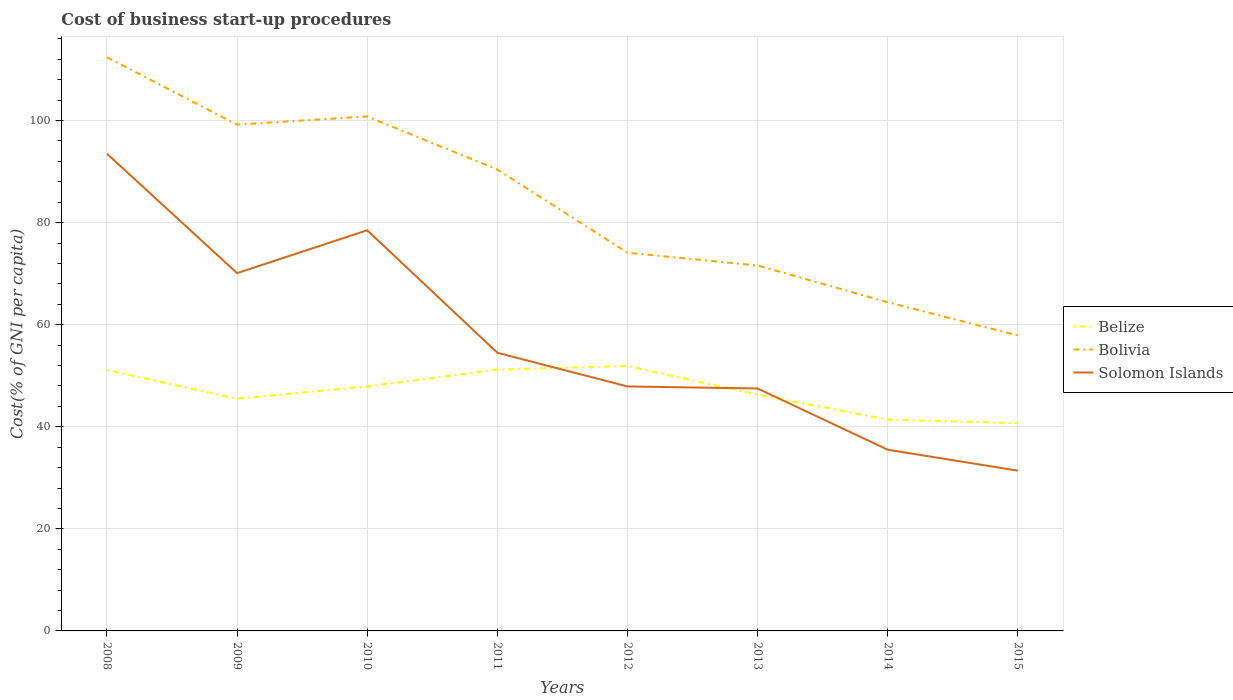How many different coloured lines are there?
Offer a terse response. 3. Across all years, what is the maximum cost of business start-up procedures in Bolivia?
Your answer should be compact. 57.9. In which year was the cost of business start-up procedures in Belize maximum?
Keep it short and to the point. 2015. What is the total cost of business start-up procedures in Bolivia in the graph?
Your answer should be very brief. 27.6. What is the difference between the highest and the second highest cost of business start-up procedures in Solomon Islands?
Give a very brief answer. 62.1. What is the difference between the highest and the lowest cost of business start-up procedures in Bolivia?
Give a very brief answer. 4. Is the cost of business start-up procedures in Solomon Islands strictly greater than the cost of business start-up procedures in Belize over the years?
Ensure brevity in your answer.  No. How many years are there in the graph?
Keep it short and to the point. 8. Does the graph contain grids?
Make the answer very short. Yes. Where does the legend appear in the graph?
Ensure brevity in your answer.  Center right. How many legend labels are there?
Provide a succinct answer. 3. How are the legend labels stacked?
Offer a terse response. Vertical. What is the title of the graph?
Your response must be concise. Cost of business start-up procedures. Does "Cyprus" appear as one of the legend labels in the graph?
Your answer should be very brief. No. What is the label or title of the X-axis?
Keep it short and to the point. Years. What is the label or title of the Y-axis?
Provide a short and direct response. Cost(% of GNI per capita). What is the Cost(% of GNI per capita) of Belize in 2008?
Provide a short and direct response. 51.1. What is the Cost(% of GNI per capita) of Bolivia in 2008?
Ensure brevity in your answer.  112.4. What is the Cost(% of GNI per capita) of Solomon Islands in 2008?
Your answer should be compact. 93.5. What is the Cost(% of GNI per capita) of Belize in 2009?
Your response must be concise. 45.5. What is the Cost(% of GNI per capita) of Bolivia in 2009?
Offer a very short reply. 99.2. What is the Cost(% of GNI per capita) in Solomon Islands in 2009?
Your answer should be compact. 70.1. What is the Cost(% of GNI per capita) in Belize in 2010?
Give a very brief answer. 47.9. What is the Cost(% of GNI per capita) of Bolivia in 2010?
Provide a short and direct response. 100.8. What is the Cost(% of GNI per capita) of Solomon Islands in 2010?
Your answer should be very brief. 78.5. What is the Cost(% of GNI per capita) in Belize in 2011?
Your response must be concise. 51.2. What is the Cost(% of GNI per capita) in Bolivia in 2011?
Keep it short and to the point. 90.4. What is the Cost(% of GNI per capita) in Solomon Islands in 2011?
Your answer should be very brief. 54.5. What is the Cost(% of GNI per capita) of Belize in 2012?
Offer a terse response. 51.9. What is the Cost(% of GNI per capita) of Bolivia in 2012?
Your answer should be very brief. 74.1. What is the Cost(% of GNI per capita) of Solomon Islands in 2012?
Your response must be concise. 47.9. What is the Cost(% of GNI per capita) in Belize in 2013?
Your answer should be compact. 46.3. What is the Cost(% of GNI per capita) of Bolivia in 2013?
Offer a very short reply. 71.6. What is the Cost(% of GNI per capita) in Solomon Islands in 2013?
Keep it short and to the point. 47.5. What is the Cost(% of GNI per capita) in Belize in 2014?
Your response must be concise. 41.4. What is the Cost(% of GNI per capita) in Bolivia in 2014?
Your answer should be compact. 64.4. What is the Cost(% of GNI per capita) of Solomon Islands in 2014?
Provide a succinct answer. 35.5. What is the Cost(% of GNI per capita) of Belize in 2015?
Provide a succinct answer. 40.7. What is the Cost(% of GNI per capita) of Bolivia in 2015?
Your answer should be very brief. 57.9. What is the Cost(% of GNI per capita) in Solomon Islands in 2015?
Provide a short and direct response. 31.4. Across all years, what is the maximum Cost(% of GNI per capita) of Belize?
Your answer should be compact. 51.9. Across all years, what is the maximum Cost(% of GNI per capita) in Bolivia?
Ensure brevity in your answer.  112.4. Across all years, what is the maximum Cost(% of GNI per capita) in Solomon Islands?
Your response must be concise. 93.5. Across all years, what is the minimum Cost(% of GNI per capita) of Belize?
Your answer should be very brief. 40.7. Across all years, what is the minimum Cost(% of GNI per capita) in Bolivia?
Your answer should be compact. 57.9. Across all years, what is the minimum Cost(% of GNI per capita) of Solomon Islands?
Provide a short and direct response. 31.4. What is the total Cost(% of GNI per capita) in Belize in the graph?
Offer a very short reply. 376. What is the total Cost(% of GNI per capita) of Bolivia in the graph?
Your response must be concise. 670.8. What is the total Cost(% of GNI per capita) in Solomon Islands in the graph?
Your answer should be compact. 458.9. What is the difference between the Cost(% of GNI per capita) of Belize in 2008 and that in 2009?
Your answer should be compact. 5.6. What is the difference between the Cost(% of GNI per capita) in Bolivia in 2008 and that in 2009?
Offer a very short reply. 13.2. What is the difference between the Cost(% of GNI per capita) of Solomon Islands in 2008 and that in 2009?
Your answer should be compact. 23.4. What is the difference between the Cost(% of GNI per capita) in Belize in 2008 and that in 2010?
Ensure brevity in your answer.  3.2. What is the difference between the Cost(% of GNI per capita) in Solomon Islands in 2008 and that in 2010?
Provide a succinct answer. 15. What is the difference between the Cost(% of GNI per capita) of Bolivia in 2008 and that in 2011?
Your response must be concise. 22. What is the difference between the Cost(% of GNI per capita) of Solomon Islands in 2008 and that in 2011?
Your answer should be compact. 39. What is the difference between the Cost(% of GNI per capita) of Bolivia in 2008 and that in 2012?
Your answer should be very brief. 38.3. What is the difference between the Cost(% of GNI per capita) of Solomon Islands in 2008 and that in 2012?
Keep it short and to the point. 45.6. What is the difference between the Cost(% of GNI per capita) in Belize in 2008 and that in 2013?
Offer a terse response. 4.8. What is the difference between the Cost(% of GNI per capita) of Bolivia in 2008 and that in 2013?
Give a very brief answer. 40.8. What is the difference between the Cost(% of GNI per capita) of Bolivia in 2008 and that in 2015?
Make the answer very short. 54.5. What is the difference between the Cost(% of GNI per capita) in Solomon Islands in 2008 and that in 2015?
Make the answer very short. 62.1. What is the difference between the Cost(% of GNI per capita) in Belize in 2009 and that in 2010?
Make the answer very short. -2.4. What is the difference between the Cost(% of GNI per capita) in Solomon Islands in 2009 and that in 2010?
Provide a short and direct response. -8.4. What is the difference between the Cost(% of GNI per capita) in Bolivia in 2009 and that in 2011?
Offer a terse response. 8.8. What is the difference between the Cost(% of GNI per capita) in Belize in 2009 and that in 2012?
Keep it short and to the point. -6.4. What is the difference between the Cost(% of GNI per capita) of Bolivia in 2009 and that in 2012?
Your answer should be very brief. 25.1. What is the difference between the Cost(% of GNI per capita) of Solomon Islands in 2009 and that in 2012?
Keep it short and to the point. 22.2. What is the difference between the Cost(% of GNI per capita) in Bolivia in 2009 and that in 2013?
Provide a short and direct response. 27.6. What is the difference between the Cost(% of GNI per capita) in Solomon Islands in 2009 and that in 2013?
Provide a succinct answer. 22.6. What is the difference between the Cost(% of GNI per capita) of Belize in 2009 and that in 2014?
Ensure brevity in your answer.  4.1. What is the difference between the Cost(% of GNI per capita) of Bolivia in 2009 and that in 2014?
Your response must be concise. 34.8. What is the difference between the Cost(% of GNI per capita) in Solomon Islands in 2009 and that in 2014?
Give a very brief answer. 34.6. What is the difference between the Cost(% of GNI per capita) of Belize in 2009 and that in 2015?
Provide a succinct answer. 4.8. What is the difference between the Cost(% of GNI per capita) in Bolivia in 2009 and that in 2015?
Offer a very short reply. 41.3. What is the difference between the Cost(% of GNI per capita) of Solomon Islands in 2009 and that in 2015?
Give a very brief answer. 38.7. What is the difference between the Cost(% of GNI per capita) of Belize in 2010 and that in 2011?
Make the answer very short. -3.3. What is the difference between the Cost(% of GNI per capita) of Bolivia in 2010 and that in 2012?
Provide a succinct answer. 26.7. What is the difference between the Cost(% of GNI per capita) in Solomon Islands in 2010 and that in 2012?
Your answer should be compact. 30.6. What is the difference between the Cost(% of GNI per capita) of Belize in 2010 and that in 2013?
Make the answer very short. 1.6. What is the difference between the Cost(% of GNI per capita) in Bolivia in 2010 and that in 2013?
Offer a terse response. 29.2. What is the difference between the Cost(% of GNI per capita) in Solomon Islands in 2010 and that in 2013?
Make the answer very short. 31. What is the difference between the Cost(% of GNI per capita) of Bolivia in 2010 and that in 2014?
Provide a short and direct response. 36.4. What is the difference between the Cost(% of GNI per capita) of Solomon Islands in 2010 and that in 2014?
Make the answer very short. 43. What is the difference between the Cost(% of GNI per capita) in Belize in 2010 and that in 2015?
Offer a very short reply. 7.2. What is the difference between the Cost(% of GNI per capita) of Bolivia in 2010 and that in 2015?
Your response must be concise. 42.9. What is the difference between the Cost(% of GNI per capita) of Solomon Islands in 2010 and that in 2015?
Keep it short and to the point. 47.1. What is the difference between the Cost(% of GNI per capita) of Belize in 2011 and that in 2012?
Your answer should be compact. -0.7. What is the difference between the Cost(% of GNI per capita) in Bolivia in 2011 and that in 2012?
Your answer should be very brief. 16.3. What is the difference between the Cost(% of GNI per capita) of Belize in 2011 and that in 2013?
Give a very brief answer. 4.9. What is the difference between the Cost(% of GNI per capita) in Bolivia in 2011 and that in 2013?
Your response must be concise. 18.8. What is the difference between the Cost(% of GNI per capita) in Solomon Islands in 2011 and that in 2013?
Ensure brevity in your answer.  7. What is the difference between the Cost(% of GNI per capita) of Bolivia in 2011 and that in 2014?
Your answer should be very brief. 26. What is the difference between the Cost(% of GNI per capita) of Solomon Islands in 2011 and that in 2014?
Ensure brevity in your answer.  19. What is the difference between the Cost(% of GNI per capita) in Belize in 2011 and that in 2015?
Ensure brevity in your answer.  10.5. What is the difference between the Cost(% of GNI per capita) of Bolivia in 2011 and that in 2015?
Provide a succinct answer. 32.5. What is the difference between the Cost(% of GNI per capita) of Solomon Islands in 2011 and that in 2015?
Offer a very short reply. 23.1. What is the difference between the Cost(% of GNI per capita) of Belize in 2012 and that in 2013?
Provide a succinct answer. 5.6. What is the difference between the Cost(% of GNI per capita) of Solomon Islands in 2012 and that in 2014?
Your answer should be very brief. 12.4. What is the difference between the Cost(% of GNI per capita) of Belize in 2012 and that in 2015?
Your answer should be very brief. 11.2. What is the difference between the Cost(% of GNI per capita) in Solomon Islands in 2013 and that in 2014?
Ensure brevity in your answer.  12. What is the difference between the Cost(% of GNI per capita) of Belize in 2013 and that in 2015?
Offer a terse response. 5.6. What is the difference between the Cost(% of GNI per capita) of Belize in 2008 and the Cost(% of GNI per capita) of Bolivia in 2009?
Your answer should be compact. -48.1. What is the difference between the Cost(% of GNI per capita) of Belize in 2008 and the Cost(% of GNI per capita) of Solomon Islands in 2009?
Ensure brevity in your answer.  -19. What is the difference between the Cost(% of GNI per capita) of Bolivia in 2008 and the Cost(% of GNI per capita) of Solomon Islands in 2009?
Offer a very short reply. 42.3. What is the difference between the Cost(% of GNI per capita) in Belize in 2008 and the Cost(% of GNI per capita) in Bolivia in 2010?
Offer a terse response. -49.7. What is the difference between the Cost(% of GNI per capita) in Belize in 2008 and the Cost(% of GNI per capita) in Solomon Islands in 2010?
Provide a short and direct response. -27.4. What is the difference between the Cost(% of GNI per capita) in Bolivia in 2008 and the Cost(% of GNI per capita) in Solomon Islands in 2010?
Offer a very short reply. 33.9. What is the difference between the Cost(% of GNI per capita) in Belize in 2008 and the Cost(% of GNI per capita) in Bolivia in 2011?
Offer a very short reply. -39.3. What is the difference between the Cost(% of GNI per capita) of Bolivia in 2008 and the Cost(% of GNI per capita) of Solomon Islands in 2011?
Give a very brief answer. 57.9. What is the difference between the Cost(% of GNI per capita) in Belize in 2008 and the Cost(% of GNI per capita) in Bolivia in 2012?
Offer a very short reply. -23. What is the difference between the Cost(% of GNI per capita) in Belize in 2008 and the Cost(% of GNI per capita) in Solomon Islands in 2012?
Your response must be concise. 3.2. What is the difference between the Cost(% of GNI per capita) of Bolivia in 2008 and the Cost(% of GNI per capita) of Solomon Islands in 2012?
Make the answer very short. 64.5. What is the difference between the Cost(% of GNI per capita) in Belize in 2008 and the Cost(% of GNI per capita) in Bolivia in 2013?
Your answer should be very brief. -20.5. What is the difference between the Cost(% of GNI per capita) in Bolivia in 2008 and the Cost(% of GNI per capita) in Solomon Islands in 2013?
Offer a very short reply. 64.9. What is the difference between the Cost(% of GNI per capita) in Belize in 2008 and the Cost(% of GNI per capita) in Solomon Islands in 2014?
Give a very brief answer. 15.6. What is the difference between the Cost(% of GNI per capita) in Bolivia in 2008 and the Cost(% of GNI per capita) in Solomon Islands in 2014?
Keep it short and to the point. 76.9. What is the difference between the Cost(% of GNI per capita) of Belize in 2008 and the Cost(% of GNI per capita) of Bolivia in 2015?
Your answer should be compact. -6.8. What is the difference between the Cost(% of GNI per capita) in Bolivia in 2008 and the Cost(% of GNI per capita) in Solomon Islands in 2015?
Ensure brevity in your answer.  81. What is the difference between the Cost(% of GNI per capita) of Belize in 2009 and the Cost(% of GNI per capita) of Bolivia in 2010?
Ensure brevity in your answer.  -55.3. What is the difference between the Cost(% of GNI per capita) in Belize in 2009 and the Cost(% of GNI per capita) in Solomon Islands in 2010?
Offer a terse response. -33. What is the difference between the Cost(% of GNI per capita) of Bolivia in 2009 and the Cost(% of GNI per capita) of Solomon Islands in 2010?
Your answer should be compact. 20.7. What is the difference between the Cost(% of GNI per capita) in Belize in 2009 and the Cost(% of GNI per capita) in Bolivia in 2011?
Keep it short and to the point. -44.9. What is the difference between the Cost(% of GNI per capita) in Bolivia in 2009 and the Cost(% of GNI per capita) in Solomon Islands in 2011?
Your answer should be very brief. 44.7. What is the difference between the Cost(% of GNI per capita) of Belize in 2009 and the Cost(% of GNI per capita) of Bolivia in 2012?
Offer a terse response. -28.6. What is the difference between the Cost(% of GNI per capita) of Belize in 2009 and the Cost(% of GNI per capita) of Solomon Islands in 2012?
Offer a very short reply. -2.4. What is the difference between the Cost(% of GNI per capita) in Bolivia in 2009 and the Cost(% of GNI per capita) in Solomon Islands in 2012?
Your answer should be compact. 51.3. What is the difference between the Cost(% of GNI per capita) in Belize in 2009 and the Cost(% of GNI per capita) in Bolivia in 2013?
Keep it short and to the point. -26.1. What is the difference between the Cost(% of GNI per capita) of Bolivia in 2009 and the Cost(% of GNI per capita) of Solomon Islands in 2013?
Offer a terse response. 51.7. What is the difference between the Cost(% of GNI per capita) in Belize in 2009 and the Cost(% of GNI per capita) in Bolivia in 2014?
Your answer should be very brief. -18.9. What is the difference between the Cost(% of GNI per capita) in Belize in 2009 and the Cost(% of GNI per capita) in Solomon Islands in 2014?
Make the answer very short. 10. What is the difference between the Cost(% of GNI per capita) in Bolivia in 2009 and the Cost(% of GNI per capita) in Solomon Islands in 2014?
Provide a short and direct response. 63.7. What is the difference between the Cost(% of GNI per capita) in Belize in 2009 and the Cost(% of GNI per capita) in Bolivia in 2015?
Offer a terse response. -12.4. What is the difference between the Cost(% of GNI per capita) in Belize in 2009 and the Cost(% of GNI per capita) in Solomon Islands in 2015?
Provide a short and direct response. 14.1. What is the difference between the Cost(% of GNI per capita) of Bolivia in 2009 and the Cost(% of GNI per capita) of Solomon Islands in 2015?
Make the answer very short. 67.8. What is the difference between the Cost(% of GNI per capita) of Belize in 2010 and the Cost(% of GNI per capita) of Bolivia in 2011?
Provide a succinct answer. -42.5. What is the difference between the Cost(% of GNI per capita) of Bolivia in 2010 and the Cost(% of GNI per capita) of Solomon Islands in 2011?
Your answer should be very brief. 46.3. What is the difference between the Cost(% of GNI per capita) of Belize in 2010 and the Cost(% of GNI per capita) of Bolivia in 2012?
Offer a terse response. -26.2. What is the difference between the Cost(% of GNI per capita) in Belize in 2010 and the Cost(% of GNI per capita) in Solomon Islands in 2012?
Your answer should be compact. 0. What is the difference between the Cost(% of GNI per capita) in Bolivia in 2010 and the Cost(% of GNI per capita) in Solomon Islands in 2012?
Ensure brevity in your answer.  52.9. What is the difference between the Cost(% of GNI per capita) in Belize in 2010 and the Cost(% of GNI per capita) in Bolivia in 2013?
Your answer should be compact. -23.7. What is the difference between the Cost(% of GNI per capita) in Bolivia in 2010 and the Cost(% of GNI per capita) in Solomon Islands in 2013?
Give a very brief answer. 53.3. What is the difference between the Cost(% of GNI per capita) of Belize in 2010 and the Cost(% of GNI per capita) of Bolivia in 2014?
Your answer should be very brief. -16.5. What is the difference between the Cost(% of GNI per capita) of Bolivia in 2010 and the Cost(% of GNI per capita) of Solomon Islands in 2014?
Provide a short and direct response. 65.3. What is the difference between the Cost(% of GNI per capita) in Bolivia in 2010 and the Cost(% of GNI per capita) in Solomon Islands in 2015?
Make the answer very short. 69.4. What is the difference between the Cost(% of GNI per capita) of Belize in 2011 and the Cost(% of GNI per capita) of Bolivia in 2012?
Your answer should be very brief. -22.9. What is the difference between the Cost(% of GNI per capita) in Belize in 2011 and the Cost(% of GNI per capita) in Solomon Islands in 2012?
Provide a succinct answer. 3.3. What is the difference between the Cost(% of GNI per capita) of Bolivia in 2011 and the Cost(% of GNI per capita) of Solomon Islands in 2012?
Offer a very short reply. 42.5. What is the difference between the Cost(% of GNI per capita) of Belize in 2011 and the Cost(% of GNI per capita) of Bolivia in 2013?
Your answer should be very brief. -20.4. What is the difference between the Cost(% of GNI per capita) in Bolivia in 2011 and the Cost(% of GNI per capita) in Solomon Islands in 2013?
Give a very brief answer. 42.9. What is the difference between the Cost(% of GNI per capita) of Belize in 2011 and the Cost(% of GNI per capita) of Bolivia in 2014?
Your answer should be compact. -13.2. What is the difference between the Cost(% of GNI per capita) in Belize in 2011 and the Cost(% of GNI per capita) in Solomon Islands in 2014?
Offer a very short reply. 15.7. What is the difference between the Cost(% of GNI per capita) of Bolivia in 2011 and the Cost(% of GNI per capita) of Solomon Islands in 2014?
Your answer should be compact. 54.9. What is the difference between the Cost(% of GNI per capita) of Belize in 2011 and the Cost(% of GNI per capita) of Solomon Islands in 2015?
Your response must be concise. 19.8. What is the difference between the Cost(% of GNI per capita) in Bolivia in 2011 and the Cost(% of GNI per capita) in Solomon Islands in 2015?
Your response must be concise. 59. What is the difference between the Cost(% of GNI per capita) in Belize in 2012 and the Cost(% of GNI per capita) in Bolivia in 2013?
Your answer should be compact. -19.7. What is the difference between the Cost(% of GNI per capita) in Belize in 2012 and the Cost(% of GNI per capita) in Solomon Islands in 2013?
Your answer should be very brief. 4.4. What is the difference between the Cost(% of GNI per capita) of Bolivia in 2012 and the Cost(% of GNI per capita) of Solomon Islands in 2013?
Offer a terse response. 26.6. What is the difference between the Cost(% of GNI per capita) of Belize in 2012 and the Cost(% of GNI per capita) of Bolivia in 2014?
Offer a terse response. -12.5. What is the difference between the Cost(% of GNI per capita) in Bolivia in 2012 and the Cost(% of GNI per capita) in Solomon Islands in 2014?
Keep it short and to the point. 38.6. What is the difference between the Cost(% of GNI per capita) of Belize in 2012 and the Cost(% of GNI per capita) of Bolivia in 2015?
Ensure brevity in your answer.  -6. What is the difference between the Cost(% of GNI per capita) of Belize in 2012 and the Cost(% of GNI per capita) of Solomon Islands in 2015?
Your answer should be very brief. 20.5. What is the difference between the Cost(% of GNI per capita) of Bolivia in 2012 and the Cost(% of GNI per capita) of Solomon Islands in 2015?
Give a very brief answer. 42.7. What is the difference between the Cost(% of GNI per capita) in Belize in 2013 and the Cost(% of GNI per capita) in Bolivia in 2014?
Keep it short and to the point. -18.1. What is the difference between the Cost(% of GNI per capita) of Bolivia in 2013 and the Cost(% of GNI per capita) of Solomon Islands in 2014?
Ensure brevity in your answer.  36.1. What is the difference between the Cost(% of GNI per capita) in Belize in 2013 and the Cost(% of GNI per capita) in Bolivia in 2015?
Your response must be concise. -11.6. What is the difference between the Cost(% of GNI per capita) of Belize in 2013 and the Cost(% of GNI per capita) of Solomon Islands in 2015?
Make the answer very short. 14.9. What is the difference between the Cost(% of GNI per capita) in Bolivia in 2013 and the Cost(% of GNI per capita) in Solomon Islands in 2015?
Offer a very short reply. 40.2. What is the difference between the Cost(% of GNI per capita) of Belize in 2014 and the Cost(% of GNI per capita) of Bolivia in 2015?
Make the answer very short. -16.5. What is the difference between the Cost(% of GNI per capita) of Belize in 2014 and the Cost(% of GNI per capita) of Solomon Islands in 2015?
Give a very brief answer. 10. What is the difference between the Cost(% of GNI per capita) of Bolivia in 2014 and the Cost(% of GNI per capita) of Solomon Islands in 2015?
Provide a short and direct response. 33. What is the average Cost(% of GNI per capita) of Bolivia per year?
Give a very brief answer. 83.85. What is the average Cost(% of GNI per capita) in Solomon Islands per year?
Make the answer very short. 57.36. In the year 2008, what is the difference between the Cost(% of GNI per capita) in Belize and Cost(% of GNI per capita) in Bolivia?
Keep it short and to the point. -61.3. In the year 2008, what is the difference between the Cost(% of GNI per capita) in Belize and Cost(% of GNI per capita) in Solomon Islands?
Offer a very short reply. -42.4. In the year 2009, what is the difference between the Cost(% of GNI per capita) in Belize and Cost(% of GNI per capita) in Bolivia?
Offer a terse response. -53.7. In the year 2009, what is the difference between the Cost(% of GNI per capita) of Belize and Cost(% of GNI per capita) of Solomon Islands?
Your response must be concise. -24.6. In the year 2009, what is the difference between the Cost(% of GNI per capita) of Bolivia and Cost(% of GNI per capita) of Solomon Islands?
Ensure brevity in your answer.  29.1. In the year 2010, what is the difference between the Cost(% of GNI per capita) in Belize and Cost(% of GNI per capita) in Bolivia?
Keep it short and to the point. -52.9. In the year 2010, what is the difference between the Cost(% of GNI per capita) in Belize and Cost(% of GNI per capita) in Solomon Islands?
Ensure brevity in your answer.  -30.6. In the year 2010, what is the difference between the Cost(% of GNI per capita) in Bolivia and Cost(% of GNI per capita) in Solomon Islands?
Offer a very short reply. 22.3. In the year 2011, what is the difference between the Cost(% of GNI per capita) of Belize and Cost(% of GNI per capita) of Bolivia?
Offer a terse response. -39.2. In the year 2011, what is the difference between the Cost(% of GNI per capita) of Belize and Cost(% of GNI per capita) of Solomon Islands?
Keep it short and to the point. -3.3. In the year 2011, what is the difference between the Cost(% of GNI per capita) in Bolivia and Cost(% of GNI per capita) in Solomon Islands?
Offer a terse response. 35.9. In the year 2012, what is the difference between the Cost(% of GNI per capita) of Belize and Cost(% of GNI per capita) of Bolivia?
Offer a terse response. -22.2. In the year 2012, what is the difference between the Cost(% of GNI per capita) of Belize and Cost(% of GNI per capita) of Solomon Islands?
Provide a short and direct response. 4. In the year 2012, what is the difference between the Cost(% of GNI per capita) of Bolivia and Cost(% of GNI per capita) of Solomon Islands?
Offer a terse response. 26.2. In the year 2013, what is the difference between the Cost(% of GNI per capita) in Belize and Cost(% of GNI per capita) in Bolivia?
Provide a succinct answer. -25.3. In the year 2013, what is the difference between the Cost(% of GNI per capita) in Belize and Cost(% of GNI per capita) in Solomon Islands?
Provide a short and direct response. -1.2. In the year 2013, what is the difference between the Cost(% of GNI per capita) of Bolivia and Cost(% of GNI per capita) of Solomon Islands?
Ensure brevity in your answer.  24.1. In the year 2014, what is the difference between the Cost(% of GNI per capita) of Belize and Cost(% of GNI per capita) of Bolivia?
Provide a succinct answer. -23. In the year 2014, what is the difference between the Cost(% of GNI per capita) in Belize and Cost(% of GNI per capita) in Solomon Islands?
Your answer should be very brief. 5.9. In the year 2014, what is the difference between the Cost(% of GNI per capita) of Bolivia and Cost(% of GNI per capita) of Solomon Islands?
Offer a terse response. 28.9. In the year 2015, what is the difference between the Cost(% of GNI per capita) of Belize and Cost(% of GNI per capita) of Bolivia?
Your answer should be compact. -17.2. In the year 2015, what is the difference between the Cost(% of GNI per capita) of Belize and Cost(% of GNI per capita) of Solomon Islands?
Your answer should be compact. 9.3. What is the ratio of the Cost(% of GNI per capita) in Belize in 2008 to that in 2009?
Your answer should be compact. 1.12. What is the ratio of the Cost(% of GNI per capita) of Bolivia in 2008 to that in 2009?
Keep it short and to the point. 1.13. What is the ratio of the Cost(% of GNI per capita) of Solomon Islands in 2008 to that in 2009?
Your answer should be compact. 1.33. What is the ratio of the Cost(% of GNI per capita) of Belize in 2008 to that in 2010?
Your response must be concise. 1.07. What is the ratio of the Cost(% of GNI per capita) in Bolivia in 2008 to that in 2010?
Make the answer very short. 1.12. What is the ratio of the Cost(% of GNI per capita) of Solomon Islands in 2008 to that in 2010?
Offer a terse response. 1.19. What is the ratio of the Cost(% of GNI per capita) of Bolivia in 2008 to that in 2011?
Offer a very short reply. 1.24. What is the ratio of the Cost(% of GNI per capita) in Solomon Islands in 2008 to that in 2011?
Give a very brief answer. 1.72. What is the ratio of the Cost(% of GNI per capita) of Belize in 2008 to that in 2012?
Offer a terse response. 0.98. What is the ratio of the Cost(% of GNI per capita) of Bolivia in 2008 to that in 2012?
Make the answer very short. 1.52. What is the ratio of the Cost(% of GNI per capita) of Solomon Islands in 2008 to that in 2012?
Your answer should be very brief. 1.95. What is the ratio of the Cost(% of GNI per capita) of Belize in 2008 to that in 2013?
Your answer should be very brief. 1.1. What is the ratio of the Cost(% of GNI per capita) of Bolivia in 2008 to that in 2013?
Keep it short and to the point. 1.57. What is the ratio of the Cost(% of GNI per capita) of Solomon Islands in 2008 to that in 2013?
Offer a terse response. 1.97. What is the ratio of the Cost(% of GNI per capita) in Belize in 2008 to that in 2014?
Your answer should be compact. 1.23. What is the ratio of the Cost(% of GNI per capita) of Bolivia in 2008 to that in 2014?
Provide a short and direct response. 1.75. What is the ratio of the Cost(% of GNI per capita) of Solomon Islands in 2008 to that in 2014?
Ensure brevity in your answer.  2.63. What is the ratio of the Cost(% of GNI per capita) in Belize in 2008 to that in 2015?
Ensure brevity in your answer.  1.26. What is the ratio of the Cost(% of GNI per capita) in Bolivia in 2008 to that in 2015?
Provide a short and direct response. 1.94. What is the ratio of the Cost(% of GNI per capita) of Solomon Islands in 2008 to that in 2015?
Offer a very short reply. 2.98. What is the ratio of the Cost(% of GNI per capita) of Belize in 2009 to that in 2010?
Your answer should be very brief. 0.95. What is the ratio of the Cost(% of GNI per capita) of Bolivia in 2009 to that in 2010?
Your response must be concise. 0.98. What is the ratio of the Cost(% of GNI per capita) in Solomon Islands in 2009 to that in 2010?
Provide a short and direct response. 0.89. What is the ratio of the Cost(% of GNI per capita) in Belize in 2009 to that in 2011?
Offer a very short reply. 0.89. What is the ratio of the Cost(% of GNI per capita) of Bolivia in 2009 to that in 2011?
Keep it short and to the point. 1.1. What is the ratio of the Cost(% of GNI per capita) in Solomon Islands in 2009 to that in 2011?
Offer a very short reply. 1.29. What is the ratio of the Cost(% of GNI per capita) in Belize in 2009 to that in 2012?
Your response must be concise. 0.88. What is the ratio of the Cost(% of GNI per capita) of Bolivia in 2009 to that in 2012?
Your answer should be very brief. 1.34. What is the ratio of the Cost(% of GNI per capita) in Solomon Islands in 2009 to that in 2012?
Your answer should be very brief. 1.46. What is the ratio of the Cost(% of GNI per capita) of Belize in 2009 to that in 2013?
Provide a short and direct response. 0.98. What is the ratio of the Cost(% of GNI per capita) of Bolivia in 2009 to that in 2013?
Ensure brevity in your answer.  1.39. What is the ratio of the Cost(% of GNI per capita) in Solomon Islands in 2009 to that in 2013?
Ensure brevity in your answer.  1.48. What is the ratio of the Cost(% of GNI per capita) in Belize in 2009 to that in 2014?
Give a very brief answer. 1.1. What is the ratio of the Cost(% of GNI per capita) of Bolivia in 2009 to that in 2014?
Ensure brevity in your answer.  1.54. What is the ratio of the Cost(% of GNI per capita) in Solomon Islands in 2009 to that in 2014?
Provide a short and direct response. 1.97. What is the ratio of the Cost(% of GNI per capita) of Belize in 2009 to that in 2015?
Give a very brief answer. 1.12. What is the ratio of the Cost(% of GNI per capita) in Bolivia in 2009 to that in 2015?
Your response must be concise. 1.71. What is the ratio of the Cost(% of GNI per capita) of Solomon Islands in 2009 to that in 2015?
Offer a terse response. 2.23. What is the ratio of the Cost(% of GNI per capita) of Belize in 2010 to that in 2011?
Your response must be concise. 0.94. What is the ratio of the Cost(% of GNI per capita) of Bolivia in 2010 to that in 2011?
Provide a short and direct response. 1.11. What is the ratio of the Cost(% of GNI per capita) of Solomon Islands in 2010 to that in 2011?
Your answer should be compact. 1.44. What is the ratio of the Cost(% of GNI per capita) in Belize in 2010 to that in 2012?
Your answer should be very brief. 0.92. What is the ratio of the Cost(% of GNI per capita) of Bolivia in 2010 to that in 2012?
Make the answer very short. 1.36. What is the ratio of the Cost(% of GNI per capita) of Solomon Islands in 2010 to that in 2012?
Provide a succinct answer. 1.64. What is the ratio of the Cost(% of GNI per capita) of Belize in 2010 to that in 2013?
Ensure brevity in your answer.  1.03. What is the ratio of the Cost(% of GNI per capita) of Bolivia in 2010 to that in 2013?
Your response must be concise. 1.41. What is the ratio of the Cost(% of GNI per capita) in Solomon Islands in 2010 to that in 2013?
Provide a short and direct response. 1.65. What is the ratio of the Cost(% of GNI per capita) of Belize in 2010 to that in 2014?
Provide a short and direct response. 1.16. What is the ratio of the Cost(% of GNI per capita) in Bolivia in 2010 to that in 2014?
Keep it short and to the point. 1.57. What is the ratio of the Cost(% of GNI per capita) in Solomon Islands in 2010 to that in 2014?
Keep it short and to the point. 2.21. What is the ratio of the Cost(% of GNI per capita) of Belize in 2010 to that in 2015?
Ensure brevity in your answer.  1.18. What is the ratio of the Cost(% of GNI per capita) of Bolivia in 2010 to that in 2015?
Ensure brevity in your answer.  1.74. What is the ratio of the Cost(% of GNI per capita) in Belize in 2011 to that in 2012?
Your answer should be compact. 0.99. What is the ratio of the Cost(% of GNI per capita) in Bolivia in 2011 to that in 2012?
Offer a terse response. 1.22. What is the ratio of the Cost(% of GNI per capita) in Solomon Islands in 2011 to that in 2012?
Provide a succinct answer. 1.14. What is the ratio of the Cost(% of GNI per capita) in Belize in 2011 to that in 2013?
Your answer should be compact. 1.11. What is the ratio of the Cost(% of GNI per capita) in Bolivia in 2011 to that in 2013?
Provide a short and direct response. 1.26. What is the ratio of the Cost(% of GNI per capita) in Solomon Islands in 2011 to that in 2013?
Offer a very short reply. 1.15. What is the ratio of the Cost(% of GNI per capita) in Belize in 2011 to that in 2014?
Offer a very short reply. 1.24. What is the ratio of the Cost(% of GNI per capita) of Bolivia in 2011 to that in 2014?
Ensure brevity in your answer.  1.4. What is the ratio of the Cost(% of GNI per capita) in Solomon Islands in 2011 to that in 2014?
Offer a terse response. 1.54. What is the ratio of the Cost(% of GNI per capita) in Belize in 2011 to that in 2015?
Your answer should be very brief. 1.26. What is the ratio of the Cost(% of GNI per capita) of Bolivia in 2011 to that in 2015?
Offer a very short reply. 1.56. What is the ratio of the Cost(% of GNI per capita) in Solomon Islands in 2011 to that in 2015?
Make the answer very short. 1.74. What is the ratio of the Cost(% of GNI per capita) of Belize in 2012 to that in 2013?
Offer a very short reply. 1.12. What is the ratio of the Cost(% of GNI per capita) of Bolivia in 2012 to that in 2013?
Provide a short and direct response. 1.03. What is the ratio of the Cost(% of GNI per capita) in Solomon Islands in 2012 to that in 2013?
Your answer should be very brief. 1.01. What is the ratio of the Cost(% of GNI per capita) of Belize in 2012 to that in 2014?
Your answer should be very brief. 1.25. What is the ratio of the Cost(% of GNI per capita) of Bolivia in 2012 to that in 2014?
Make the answer very short. 1.15. What is the ratio of the Cost(% of GNI per capita) in Solomon Islands in 2012 to that in 2014?
Make the answer very short. 1.35. What is the ratio of the Cost(% of GNI per capita) in Belize in 2012 to that in 2015?
Make the answer very short. 1.28. What is the ratio of the Cost(% of GNI per capita) in Bolivia in 2012 to that in 2015?
Your answer should be very brief. 1.28. What is the ratio of the Cost(% of GNI per capita) in Solomon Islands in 2012 to that in 2015?
Provide a succinct answer. 1.53. What is the ratio of the Cost(% of GNI per capita) of Belize in 2013 to that in 2014?
Your answer should be very brief. 1.12. What is the ratio of the Cost(% of GNI per capita) of Bolivia in 2013 to that in 2014?
Make the answer very short. 1.11. What is the ratio of the Cost(% of GNI per capita) of Solomon Islands in 2013 to that in 2014?
Make the answer very short. 1.34. What is the ratio of the Cost(% of GNI per capita) in Belize in 2013 to that in 2015?
Your answer should be very brief. 1.14. What is the ratio of the Cost(% of GNI per capita) in Bolivia in 2013 to that in 2015?
Ensure brevity in your answer.  1.24. What is the ratio of the Cost(% of GNI per capita) in Solomon Islands in 2013 to that in 2015?
Offer a terse response. 1.51. What is the ratio of the Cost(% of GNI per capita) in Belize in 2014 to that in 2015?
Offer a terse response. 1.02. What is the ratio of the Cost(% of GNI per capita) of Bolivia in 2014 to that in 2015?
Your answer should be very brief. 1.11. What is the ratio of the Cost(% of GNI per capita) in Solomon Islands in 2014 to that in 2015?
Offer a very short reply. 1.13. What is the difference between the highest and the second highest Cost(% of GNI per capita) in Belize?
Your answer should be very brief. 0.7. What is the difference between the highest and the second highest Cost(% of GNI per capita) in Bolivia?
Provide a succinct answer. 11.6. What is the difference between the highest and the second highest Cost(% of GNI per capita) in Solomon Islands?
Offer a terse response. 15. What is the difference between the highest and the lowest Cost(% of GNI per capita) in Belize?
Offer a terse response. 11.2. What is the difference between the highest and the lowest Cost(% of GNI per capita) of Bolivia?
Ensure brevity in your answer.  54.5. What is the difference between the highest and the lowest Cost(% of GNI per capita) in Solomon Islands?
Offer a very short reply. 62.1. 